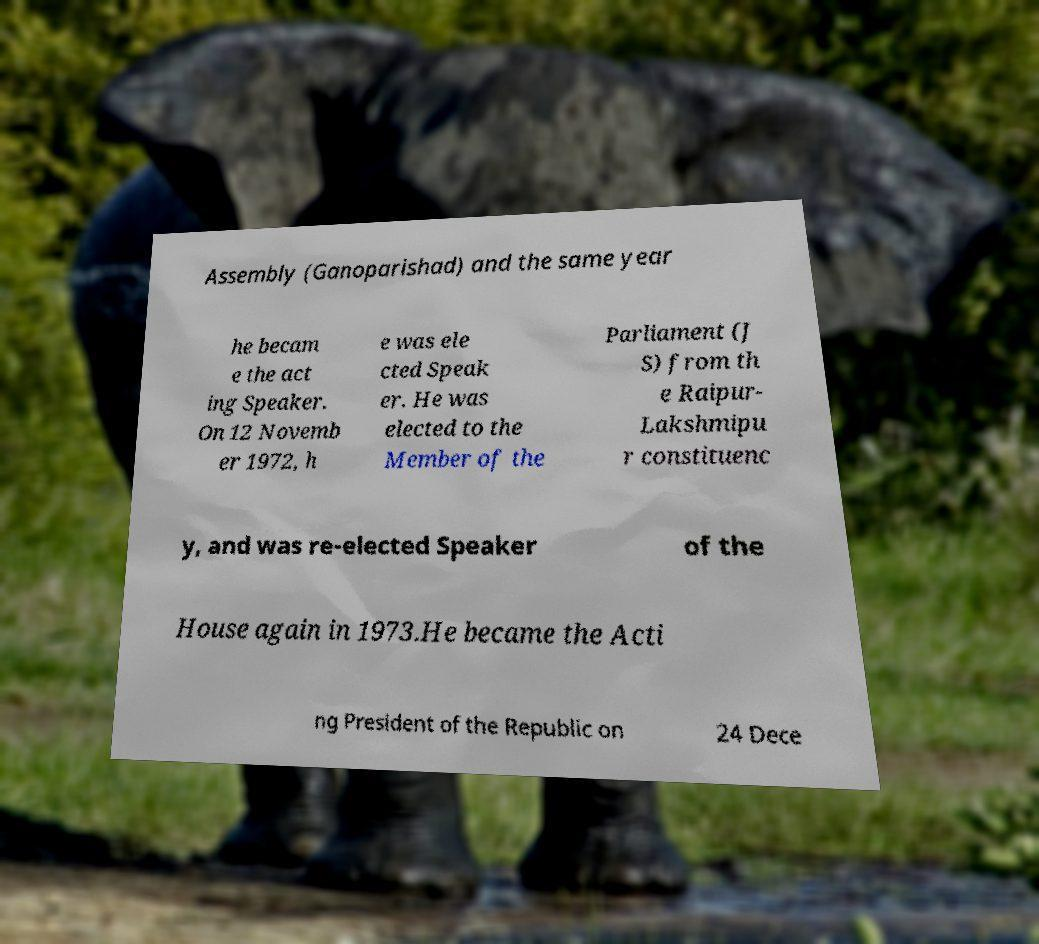Please identify and transcribe the text found in this image. Assembly (Ganoparishad) and the same year he becam e the act ing Speaker. On 12 Novemb er 1972, h e was ele cted Speak er. He was elected to the Member of the Parliament (J S) from th e Raipur- Lakshmipu r constituenc y, and was re-elected Speaker of the House again in 1973.He became the Acti ng President of the Republic on 24 Dece 